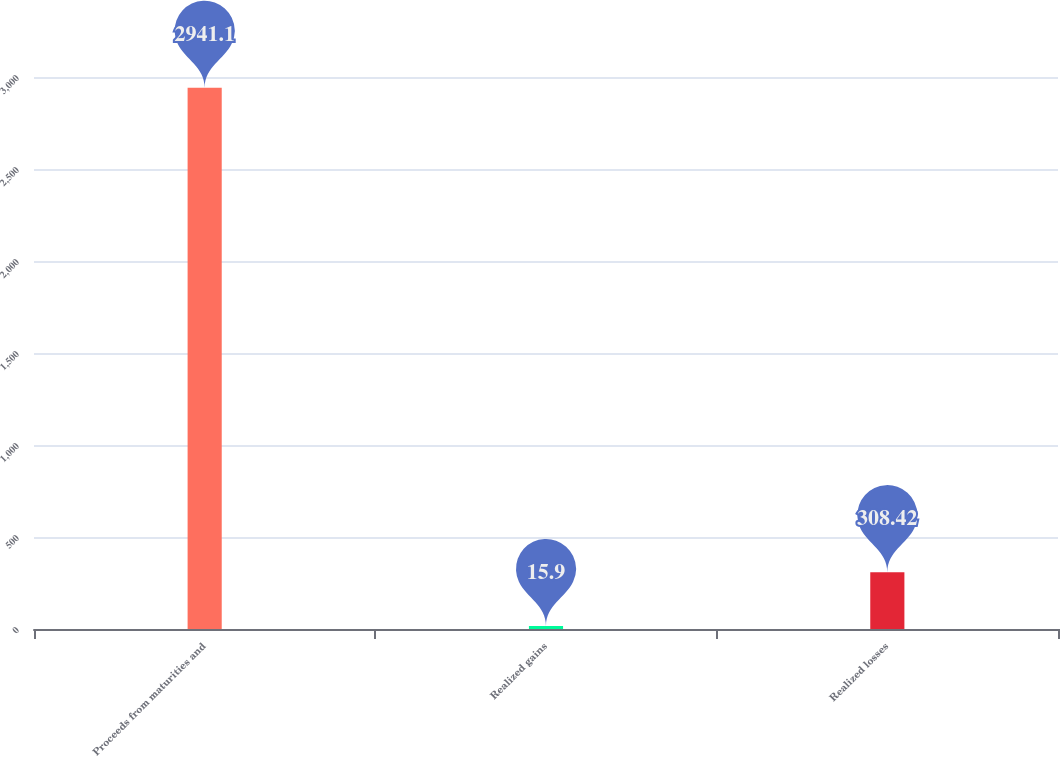<chart> <loc_0><loc_0><loc_500><loc_500><bar_chart><fcel>Proceeds from maturities and<fcel>Realized gains<fcel>Realized losses<nl><fcel>2941.1<fcel>15.9<fcel>308.42<nl></chart> 